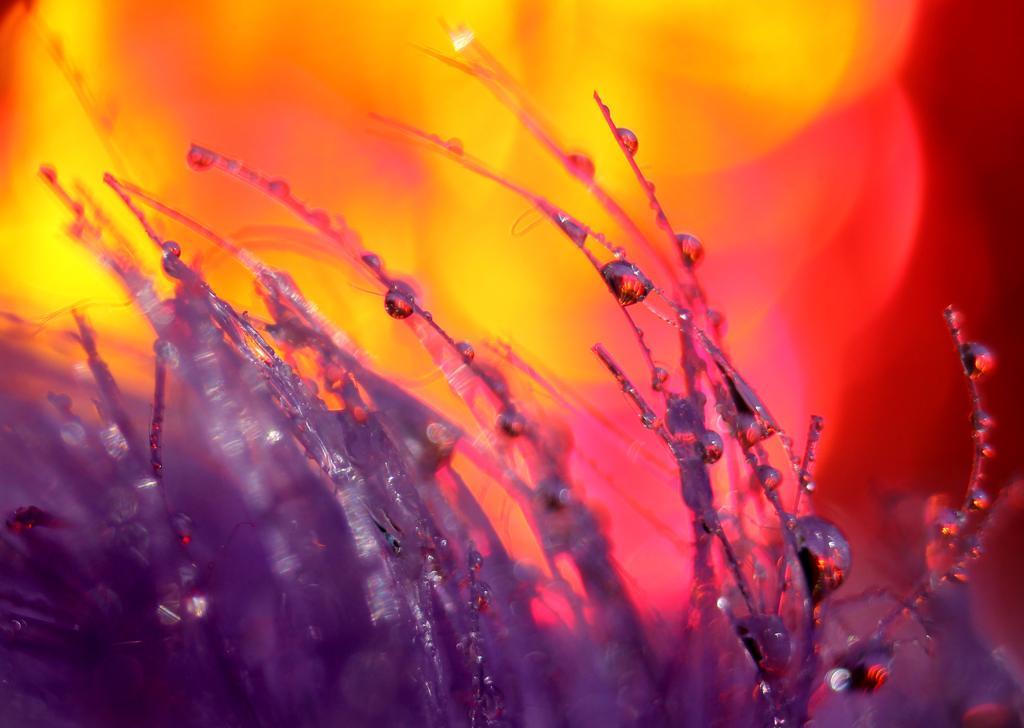Describe this image in one or two sentences. In this picture I can see the silver color things in front and I see that it is colorful in the background. 